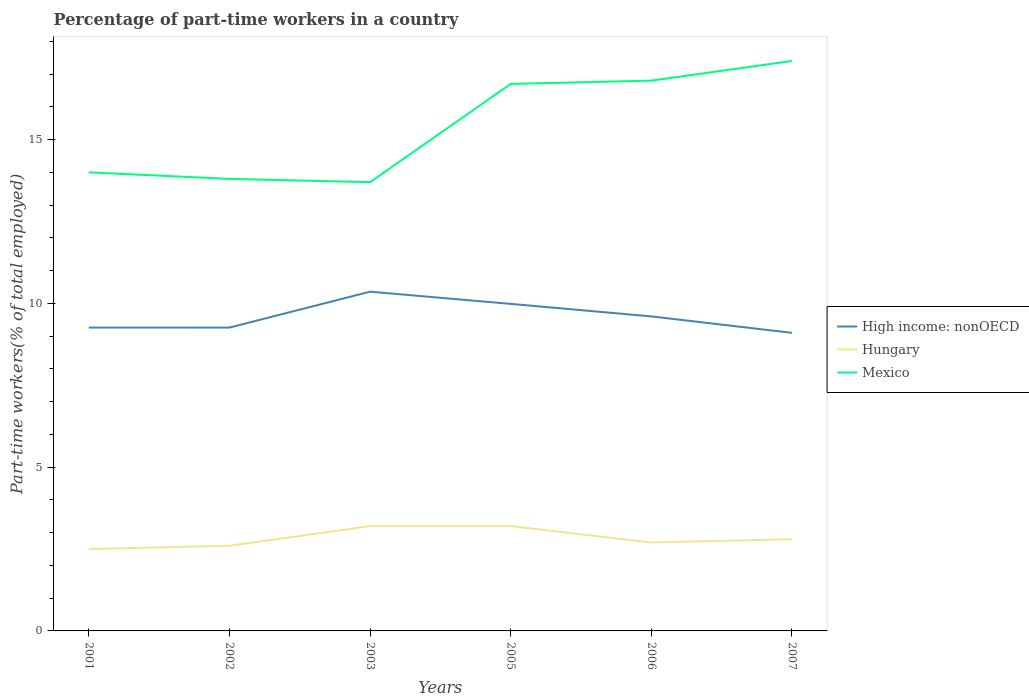How many different coloured lines are there?
Your answer should be compact. 3. Across all years, what is the maximum percentage of part-time workers in High income: nonOECD?
Provide a succinct answer. 9.1. What is the total percentage of part-time workers in Hungary in the graph?
Offer a terse response. 0. What is the difference between the highest and the second highest percentage of part-time workers in Hungary?
Your answer should be compact. 0.7. How many years are there in the graph?
Keep it short and to the point. 6. What is the difference between two consecutive major ticks on the Y-axis?
Make the answer very short. 5. Are the values on the major ticks of Y-axis written in scientific E-notation?
Provide a short and direct response. No. Does the graph contain grids?
Offer a terse response. No. Where does the legend appear in the graph?
Your answer should be very brief. Center right. How are the legend labels stacked?
Offer a terse response. Vertical. What is the title of the graph?
Offer a very short reply. Percentage of part-time workers in a country. What is the label or title of the Y-axis?
Offer a terse response. Part-time workers(% of total employed). What is the Part-time workers(% of total employed) in High income: nonOECD in 2001?
Your answer should be compact. 9.26. What is the Part-time workers(% of total employed) in Mexico in 2001?
Your answer should be very brief. 14. What is the Part-time workers(% of total employed) of High income: nonOECD in 2002?
Your answer should be compact. 9.26. What is the Part-time workers(% of total employed) of Hungary in 2002?
Give a very brief answer. 2.6. What is the Part-time workers(% of total employed) of Mexico in 2002?
Make the answer very short. 13.8. What is the Part-time workers(% of total employed) of High income: nonOECD in 2003?
Your answer should be compact. 10.36. What is the Part-time workers(% of total employed) in Hungary in 2003?
Make the answer very short. 3.2. What is the Part-time workers(% of total employed) in Mexico in 2003?
Provide a succinct answer. 13.7. What is the Part-time workers(% of total employed) in High income: nonOECD in 2005?
Make the answer very short. 9.98. What is the Part-time workers(% of total employed) in Hungary in 2005?
Provide a succinct answer. 3.2. What is the Part-time workers(% of total employed) of Mexico in 2005?
Your answer should be compact. 16.7. What is the Part-time workers(% of total employed) in High income: nonOECD in 2006?
Ensure brevity in your answer.  9.6. What is the Part-time workers(% of total employed) in Hungary in 2006?
Offer a very short reply. 2.7. What is the Part-time workers(% of total employed) of Mexico in 2006?
Provide a succinct answer. 16.8. What is the Part-time workers(% of total employed) of High income: nonOECD in 2007?
Offer a very short reply. 9.1. What is the Part-time workers(% of total employed) in Hungary in 2007?
Keep it short and to the point. 2.8. What is the Part-time workers(% of total employed) of Mexico in 2007?
Your answer should be compact. 17.4. Across all years, what is the maximum Part-time workers(% of total employed) in High income: nonOECD?
Provide a succinct answer. 10.36. Across all years, what is the maximum Part-time workers(% of total employed) in Hungary?
Your answer should be compact. 3.2. Across all years, what is the maximum Part-time workers(% of total employed) in Mexico?
Keep it short and to the point. 17.4. Across all years, what is the minimum Part-time workers(% of total employed) of High income: nonOECD?
Give a very brief answer. 9.1. Across all years, what is the minimum Part-time workers(% of total employed) in Hungary?
Provide a succinct answer. 2.5. Across all years, what is the minimum Part-time workers(% of total employed) in Mexico?
Your response must be concise. 13.7. What is the total Part-time workers(% of total employed) of High income: nonOECD in the graph?
Give a very brief answer. 57.57. What is the total Part-time workers(% of total employed) of Mexico in the graph?
Give a very brief answer. 92.4. What is the difference between the Part-time workers(% of total employed) in High income: nonOECD in 2001 and that in 2002?
Your answer should be compact. 0. What is the difference between the Part-time workers(% of total employed) of Mexico in 2001 and that in 2002?
Your answer should be compact. 0.2. What is the difference between the Part-time workers(% of total employed) in High income: nonOECD in 2001 and that in 2003?
Keep it short and to the point. -1.1. What is the difference between the Part-time workers(% of total employed) of Hungary in 2001 and that in 2003?
Provide a succinct answer. -0.7. What is the difference between the Part-time workers(% of total employed) in Mexico in 2001 and that in 2003?
Make the answer very short. 0.3. What is the difference between the Part-time workers(% of total employed) of High income: nonOECD in 2001 and that in 2005?
Keep it short and to the point. -0.72. What is the difference between the Part-time workers(% of total employed) of Mexico in 2001 and that in 2005?
Your response must be concise. -2.7. What is the difference between the Part-time workers(% of total employed) in High income: nonOECD in 2001 and that in 2006?
Give a very brief answer. -0.34. What is the difference between the Part-time workers(% of total employed) in High income: nonOECD in 2001 and that in 2007?
Make the answer very short. 0.16. What is the difference between the Part-time workers(% of total employed) in High income: nonOECD in 2002 and that in 2003?
Provide a short and direct response. -1.1. What is the difference between the Part-time workers(% of total employed) in Hungary in 2002 and that in 2003?
Provide a short and direct response. -0.6. What is the difference between the Part-time workers(% of total employed) in High income: nonOECD in 2002 and that in 2005?
Provide a short and direct response. -0.72. What is the difference between the Part-time workers(% of total employed) of Mexico in 2002 and that in 2005?
Your response must be concise. -2.9. What is the difference between the Part-time workers(% of total employed) in High income: nonOECD in 2002 and that in 2006?
Provide a short and direct response. -0.34. What is the difference between the Part-time workers(% of total employed) of High income: nonOECD in 2002 and that in 2007?
Your response must be concise. 0.16. What is the difference between the Part-time workers(% of total employed) of Hungary in 2002 and that in 2007?
Provide a short and direct response. -0.2. What is the difference between the Part-time workers(% of total employed) of High income: nonOECD in 2003 and that in 2005?
Provide a succinct answer. 0.37. What is the difference between the Part-time workers(% of total employed) of High income: nonOECD in 2003 and that in 2006?
Provide a succinct answer. 0.75. What is the difference between the Part-time workers(% of total employed) of High income: nonOECD in 2003 and that in 2007?
Ensure brevity in your answer.  1.26. What is the difference between the Part-time workers(% of total employed) of High income: nonOECD in 2005 and that in 2006?
Ensure brevity in your answer.  0.38. What is the difference between the Part-time workers(% of total employed) in Mexico in 2005 and that in 2006?
Keep it short and to the point. -0.1. What is the difference between the Part-time workers(% of total employed) in High income: nonOECD in 2005 and that in 2007?
Provide a succinct answer. 0.88. What is the difference between the Part-time workers(% of total employed) of Hungary in 2005 and that in 2007?
Your response must be concise. 0.4. What is the difference between the Part-time workers(% of total employed) in Mexico in 2005 and that in 2007?
Your answer should be very brief. -0.7. What is the difference between the Part-time workers(% of total employed) in High income: nonOECD in 2006 and that in 2007?
Offer a terse response. 0.5. What is the difference between the Part-time workers(% of total employed) of Hungary in 2006 and that in 2007?
Your response must be concise. -0.1. What is the difference between the Part-time workers(% of total employed) of Mexico in 2006 and that in 2007?
Your answer should be very brief. -0.6. What is the difference between the Part-time workers(% of total employed) of High income: nonOECD in 2001 and the Part-time workers(% of total employed) of Hungary in 2002?
Your answer should be compact. 6.66. What is the difference between the Part-time workers(% of total employed) of High income: nonOECD in 2001 and the Part-time workers(% of total employed) of Mexico in 2002?
Your response must be concise. -4.54. What is the difference between the Part-time workers(% of total employed) of High income: nonOECD in 2001 and the Part-time workers(% of total employed) of Hungary in 2003?
Give a very brief answer. 6.06. What is the difference between the Part-time workers(% of total employed) in High income: nonOECD in 2001 and the Part-time workers(% of total employed) in Mexico in 2003?
Ensure brevity in your answer.  -4.44. What is the difference between the Part-time workers(% of total employed) of High income: nonOECD in 2001 and the Part-time workers(% of total employed) of Hungary in 2005?
Offer a terse response. 6.06. What is the difference between the Part-time workers(% of total employed) in High income: nonOECD in 2001 and the Part-time workers(% of total employed) in Mexico in 2005?
Your answer should be very brief. -7.44. What is the difference between the Part-time workers(% of total employed) of Hungary in 2001 and the Part-time workers(% of total employed) of Mexico in 2005?
Your answer should be very brief. -14.2. What is the difference between the Part-time workers(% of total employed) of High income: nonOECD in 2001 and the Part-time workers(% of total employed) of Hungary in 2006?
Your answer should be compact. 6.56. What is the difference between the Part-time workers(% of total employed) of High income: nonOECD in 2001 and the Part-time workers(% of total employed) of Mexico in 2006?
Offer a very short reply. -7.54. What is the difference between the Part-time workers(% of total employed) in Hungary in 2001 and the Part-time workers(% of total employed) in Mexico in 2006?
Offer a terse response. -14.3. What is the difference between the Part-time workers(% of total employed) in High income: nonOECD in 2001 and the Part-time workers(% of total employed) in Hungary in 2007?
Keep it short and to the point. 6.46. What is the difference between the Part-time workers(% of total employed) in High income: nonOECD in 2001 and the Part-time workers(% of total employed) in Mexico in 2007?
Offer a very short reply. -8.14. What is the difference between the Part-time workers(% of total employed) of Hungary in 2001 and the Part-time workers(% of total employed) of Mexico in 2007?
Provide a succinct answer. -14.9. What is the difference between the Part-time workers(% of total employed) of High income: nonOECD in 2002 and the Part-time workers(% of total employed) of Hungary in 2003?
Provide a succinct answer. 6.06. What is the difference between the Part-time workers(% of total employed) of High income: nonOECD in 2002 and the Part-time workers(% of total employed) of Mexico in 2003?
Offer a terse response. -4.44. What is the difference between the Part-time workers(% of total employed) in Hungary in 2002 and the Part-time workers(% of total employed) in Mexico in 2003?
Your response must be concise. -11.1. What is the difference between the Part-time workers(% of total employed) of High income: nonOECD in 2002 and the Part-time workers(% of total employed) of Hungary in 2005?
Offer a very short reply. 6.06. What is the difference between the Part-time workers(% of total employed) of High income: nonOECD in 2002 and the Part-time workers(% of total employed) of Mexico in 2005?
Your answer should be compact. -7.44. What is the difference between the Part-time workers(% of total employed) of Hungary in 2002 and the Part-time workers(% of total employed) of Mexico in 2005?
Offer a terse response. -14.1. What is the difference between the Part-time workers(% of total employed) in High income: nonOECD in 2002 and the Part-time workers(% of total employed) in Hungary in 2006?
Provide a succinct answer. 6.56. What is the difference between the Part-time workers(% of total employed) of High income: nonOECD in 2002 and the Part-time workers(% of total employed) of Mexico in 2006?
Your response must be concise. -7.54. What is the difference between the Part-time workers(% of total employed) of Hungary in 2002 and the Part-time workers(% of total employed) of Mexico in 2006?
Offer a terse response. -14.2. What is the difference between the Part-time workers(% of total employed) in High income: nonOECD in 2002 and the Part-time workers(% of total employed) in Hungary in 2007?
Provide a short and direct response. 6.46. What is the difference between the Part-time workers(% of total employed) of High income: nonOECD in 2002 and the Part-time workers(% of total employed) of Mexico in 2007?
Make the answer very short. -8.14. What is the difference between the Part-time workers(% of total employed) of Hungary in 2002 and the Part-time workers(% of total employed) of Mexico in 2007?
Offer a very short reply. -14.8. What is the difference between the Part-time workers(% of total employed) of High income: nonOECD in 2003 and the Part-time workers(% of total employed) of Hungary in 2005?
Your answer should be compact. 7.16. What is the difference between the Part-time workers(% of total employed) of High income: nonOECD in 2003 and the Part-time workers(% of total employed) of Mexico in 2005?
Your answer should be compact. -6.34. What is the difference between the Part-time workers(% of total employed) in High income: nonOECD in 2003 and the Part-time workers(% of total employed) in Hungary in 2006?
Make the answer very short. 7.66. What is the difference between the Part-time workers(% of total employed) of High income: nonOECD in 2003 and the Part-time workers(% of total employed) of Mexico in 2006?
Give a very brief answer. -6.44. What is the difference between the Part-time workers(% of total employed) of High income: nonOECD in 2003 and the Part-time workers(% of total employed) of Hungary in 2007?
Make the answer very short. 7.56. What is the difference between the Part-time workers(% of total employed) in High income: nonOECD in 2003 and the Part-time workers(% of total employed) in Mexico in 2007?
Keep it short and to the point. -7.04. What is the difference between the Part-time workers(% of total employed) in High income: nonOECD in 2005 and the Part-time workers(% of total employed) in Hungary in 2006?
Ensure brevity in your answer.  7.28. What is the difference between the Part-time workers(% of total employed) of High income: nonOECD in 2005 and the Part-time workers(% of total employed) of Mexico in 2006?
Your answer should be compact. -6.82. What is the difference between the Part-time workers(% of total employed) in High income: nonOECD in 2005 and the Part-time workers(% of total employed) in Hungary in 2007?
Offer a very short reply. 7.18. What is the difference between the Part-time workers(% of total employed) in High income: nonOECD in 2005 and the Part-time workers(% of total employed) in Mexico in 2007?
Offer a terse response. -7.42. What is the difference between the Part-time workers(% of total employed) of High income: nonOECD in 2006 and the Part-time workers(% of total employed) of Hungary in 2007?
Give a very brief answer. 6.8. What is the difference between the Part-time workers(% of total employed) of High income: nonOECD in 2006 and the Part-time workers(% of total employed) of Mexico in 2007?
Offer a terse response. -7.8. What is the difference between the Part-time workers(% of total employed) in Hungary in 2006 and the Part-time workers(% of total employed) in Mexico in 2007?
Ensure brevity in your answer.  -14.7. What is the average Part-time workers(% of total employed) in High income: nonOECD per year?
Ensure brevity in your answer.  9.59. What is the average Part-time workers(% of total employed) in Hungary per year?
Give a very brief answer. 2.83. In the year 2001, what is the difference between the Part-time workers(% of total employed) in High income: nonOECD and Part-time workers(% of total employed) in Hungary?
Provide a succinct answer. 6.76. In the year 2001, what is the difference between the Part-time workers(% of total employed) of High income: nonOECD and Part-time workers(% of total employed) of Mexico?
Ensure brevity in your answer.  -4.74. In the year 2002, what is the difference between the Part-time workers(% of total employed) in High income: nonOECD and Part-time workers(% of total employed) in Hungary?
Provide a succinct answer. 6.66. In the year 2002, what is the difference between the Part-time workers(% of total employed) of High income: nonOECD and Part-time workers(% of total employed) of Mexico?
Your response must be concise. -4.54. In the year 2002, what is the difference between the Part-time workers(% of total employed) of Hungary and Part-time workers(% of total employed) of Mexico?
Your answer should be very brief. -11.2. In the year 2003, what is the difference between the Part-time workers(% of total employed) of High income: nonOECD and Part-time workers(% of total employed) of Hungary?
Ensure brevity in your answer.  7.16. In the year 2003, what is the difference between the Part-time workers(% of total employed) of High income: nonOECD and Part-time workers(% of total employed) of Mexico?
Provide a short and direct response. -3.34. In the year 2005, what is the difference between the Part-time workers(% of total employed) in High income: nonOECD and Part-time workers(% of total employed) in Hungary?
Your answer should be very brief. 6.78. In the year 2005, what is the difference between the Part-time workers(% of total employed) of High income: nonOECD and Part-time workers(% of total employed) of Mexico?
Provide a succinct answer. -6.72. In the year 2006, what is the difference between the Part-time workers(% of total employed) of High income: nonOECD and Part-time workers(% of total employed) of Hungary?
Your answer should be compact. 6.9. In the year 2006, what is the difference between the Part-time workers(% of total employed) in High income: nonOECD and Part-time workers(% of total employed) in Mexico?
Provide a succinct answer. -7.2. In the year 2006, what is the difference between the Part-time workers(% of total employed) of Hungary and Part-time workers(% of total employed) of Mexico?
Make the answer very short. -14.1. In the year 2007, what is the difference between the Part-time workers(% of total employed) in High income: nonOECD and Part-time workers(% of total employed) in Hungary?
Give a very brief answer. 6.3. In the year 2007, what is the difference between the Part-time workers(% of total employed) in High income: nonOECD and Part-time workers(% of total employed) in Mexico?
Provide a short and direct response. -8.3. In the year 2007, what is the difference between the Part-time workers(% of total employed) of Hungary and Part-time workers(% of total employed) of Mexico?
Ensure brevity in your answer.  -14.6. What is the ratio of the Part-time workers(% of total employed) of Hungary in 2001 to that in 2002?
Ensure brevity in your answer.  0.96. What is the ratio of the Part-time workers(% of total employed) in Mexico in 2001 to that in 2002?
Provide a short and direct response. 1.01. What is the ratio of the Part-time workers(% of total employed) of High income: nonOECD in 2001 to that in 2003?
Make the answer very short. 0.89. What is the ratio of the Part-time workers(% of total employed) of Hungary in 2001 to that in 2003?
Your answer should be compact. 0.78. What is the ratio of the Part-time workers(% of total employed) of Mexico in 2001 to that in 2003?
Offer a very short reply. 1.02. What is the ratio of the Part-time workers(% of total employed) in High income: nonOECD in 2001 to that in 2005?
Offer a terse response. 0.93. What is the ratio of the Part-time workers(% of total employed) in Hungary in 2001 to that in 2005?
Ensure brevity in your answer.  0.78. What is the ratio of the Part-time workers(% of total employed) of Mexico in 2001 to that in 2005?
Offer a terse response. 0.84. What is the ratio of the Part-time workers(% of total employed) in High income: nonOECD in 2001 to that in 2006?
Your response must be concise. 0.96. What is the ratio of the Part-time workers(% of total employed) of Hungary in 2001 to that in 2006?
Your answer should be compact. 0.93. What is the ratio of the Part-time workers(% of total employed) in High income: nonOECD in 2001 to that in 2007?
Provide a succinct answer. 1.02. What is the ratio of the Part-time workers(% of total employed) in Hungary in 2001 to that in 2007?
Provide a succinct answer. 0.89. What is the ratio of the Part-time workers(% of total employed) of Mexico in 2001 to that in 2007?
Ensure brevity in your answer.  0.8. What is the ratio of the Part-time workers(% of total employed) in High income: nonOECD in 2002 to that in 2003?
Offer a very short reply. 0.89. What is the ratio of the Part-time workers(% of total employed) in Hungary in 2002 to that in 2003?
Your answer should be very brief. 0.81. What is the ratio of the Part-time workers(% of total employed) of Mexico in 2002 to that in 2003?
Give a very brief answer. 1.01. What is the ratio of the Part-time workers(% of total employed) of High income: nonOECD in 2002 to that in 2005?
Offer a terse response. 0.93. What is the ratio of the Part-time workers(% of total employed) in Hungary in 2002 to that in 2005?
Ensure brevity in your answer.  0.81. What is the ratio of the Part-time workers(% of total employed) in Mexico in 2002 to that in 2005?
Your answer should be very brief. 0.83. What is the ratio of the Part-time workers(% of total employed) of High income: nonOECD in 2002 to that in 2006?
Ensure brevity in your answer.  0.96. What is the ratio of the Part-time workers(% of total employed) of Mexico in 2002 to that in 2006?
Keep it short and to the point. 0.82. What is the ratio of the Part-time workers(% of total employed) in High income: nonOECD in 2002 to that in 2007?
Provide a succinct answer. 1.02. What is the ratio of the Part-time workers(% of total employed) in Mexico in 2002 to that in 2007?
Ensure brevity in your answer.  0.79. What is the ratio of the Part-time workers(% of total employed) of High income: nonOECD in 2003 to that in 2005?
Provide a short and direct response. 1.04. What is the ratio of the Part-time workers(% of total employed) in Mexico in 2003 to that in 2005?
Provide a short and direct response. 0.82. What is the ratio of the Part-time workers(% of total employed) of High income: nonOECD in 2003 to that in 2006?
Provide a succinct answer. 1.08. What is the ratio of the Part-time workers(% of total employed) in Hungary in 2003 to that in 2006?
Provide a succinct answer. 1.19. What is the ratio of the Part-time workers(% of total employed) of Mexico in 2003 to that in 2006?
Keep it short and to the point. 0.82. What is the ratio of the Part-time workers(% of total employed) of High income: nonOECD in 2003 to that in 2007?
Give a very brief answer. 1.14. What is the ratio of the Part-time workers(% of total employed) of Mexico in 2003 to that in 2007?
Give a very brief answer. 0.79. What is the ratio of the Part-time workers(% of total employed) of High income: nonOECD in 2005 to that in 2006?
Make the answer very short. 1.04. What is the ratio of the Part-time workers(% of total employed) of Hungary in 2005 to that in 2006?
Your response must be concise. 1.19. What is the ratio of the Part-time workers(% of total employed) of Mexico in 2005 to that in 2006?
Offer a very short reply. 0.99. What is the ratio of the Part-time workers(% of total employed) in High income: nonOECD in 2005 to that in 2007?
Give a very brief answer. 1.1. What is the ratio of the Part-time workers(% of total employed) in Mexico in 2005 to that in 2007?
Make the answer very short. 0.96. What is the ratio of the Part-time workers(% of total employed) in High income: nonOECD in 2006 to that in 2007?
Your answer should be compact. 1.06. What is the ratio of the Part-time workers(% of total employed) in Mexico in 2006 to that in 2007?
Make the answer very short. 0.97. What is the difference between the highest and the second highest Part-time workers(% of total employed) in High income: nonOECD?
Your response must be concise. 0.37. What is the difference between the highest and the second highest Part-time workers(% of total employed) in Hungary?
Provide a short and direct response. 0. What is the difference between the highest and the lowest Part-time workers(% of total employed) in High income: nonOECD?
Make the answer very short. 1.26. 